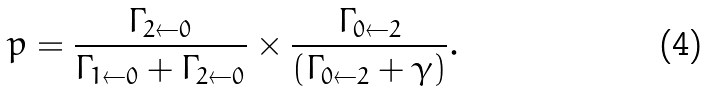<formula> <loc_0><loc_0><loc_500><loc_500>p = \frac { \Gamma _ { 2 \leftarrow 0 } } { \Gamma _ { 1 \leftarrow 0 } + \Gamma _ { 2 \leftarrow 0 } } \times \frac { \Gamma _ { 0 \leftarrow 2 } } { ( \Gamma _ { 0 \leftarrow 2 } + \gamma ) } .</formula> 